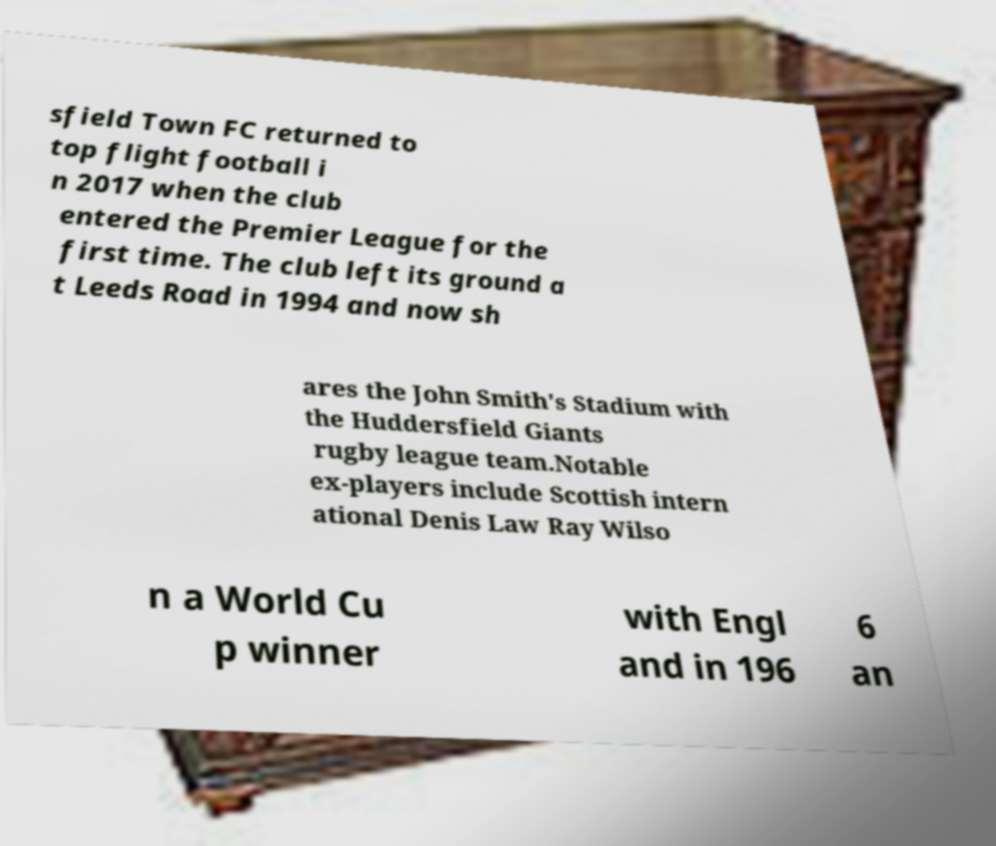Could you extract and type out the text from this image? sfield Town FC returned to top flight football i n 2017 when the club entered the Premier League for the first time. The club left its ground a t Leeds Road in 1994 and now sh ares the John Smith's Stadium with the Huddersfield Giants rugby league team.Notable ex-players include Scottish intern ational Denis Law Ray Wilso n a World Cu p winner with Engl and in 196 6 an 